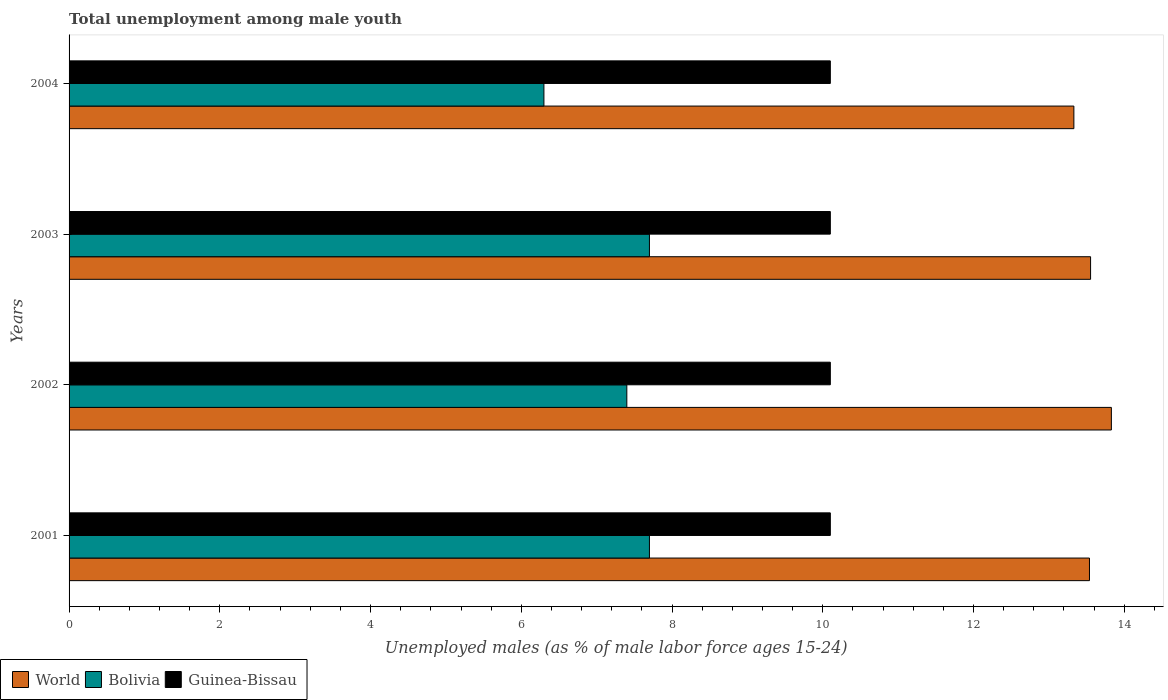How many different coloured bars are there?
Keep it short and to the point. 3. How many groups of bars are there?
Your answer should be very brief. 4. Are the number of bars on each tick of the Y-axis equal?
Offer a terse response. Yes. How many bars are there on the 2nd tick from the top?
Provide a short and direct response. 3. How many bars are there on the 2nd tick from the bottom?
Ensure brevity in your answer.  3. What is the label of the 3rd group of bars from the top?
Offer a terse response. 2002. In how many cases, is the number of bars for a given year not equal to the number of legend labels?
Keep it short and to the point. 0. What is the percentage of unemployed males in in World in 2004?
Give a very brief answer. 13.33. Across all years, what is the maximum percentage of unemployed males in in World?
Your response must be concise. 13.83. Across all years, what is the minimum percentage of unemployed males in in World?
Offer a terse response. 13.33. In which year was the percentage of unemployed males in in World minimum?
Make the answer very short. 2004. What is the total percentage of unemployed males in in Guinea-Bissau in the graph?
Provide a short and direct response. 40.4. What is the difference between the percentage of unemployed males in in World in 2001 and that in 2002?
Ensure brevity in your answer.  -0.29. What is the difference between the percentage of unemployed males in in Guinea-Bissau in 2001 and the percentage of unemployed males in in World in 2002?
Ensure brevity in your answer.  -3.73. What is the average percentage of unemployed males in in Guinea-Bissau per year?
Make the answer very short. 10.1. In the year 2003, what is the difference between the percentage of unemployed males in in Bolivia and percentage of unemployed males in in World?
Provide a short and direct response. -5.85. In how many years, is the percentage of unemployed males in in Bolivia greater than 9.6 %?
Provide a short and direct response. 0. Is the difference between the percentage of unemployed males in in Bolivia in 2002 and 2003 greater than the difference between the percentage of unemployed males in in World in 2002 and 2003?
Ensure brevity in your answer.  No. What is the difference between the highest and the lowest percentage of unemployed males in in Guinea-Bissau?
Your response must be concise. 0. What does the 3rd bar from the bottom in 2001 represents?
Provide a short and direct response. Guinea-Bissau. Are all the bars in the graph horizontal?
Give a very brief answer. Yes. How many years are there in the graph?
Give a very brief answer. 4. What is the difference between two consecutive major ticks on the X-axis?
Provide a short and direct response. 2. Are the values on the major ticks of X-axis written in scientific E-notation?
Offer a terse response. No. Does the graph contain any zero values?
Provide a short and direct response. No. Where does the legend appear in the graph?
Your answer should be compact. Bottom left. How many legend labels are there?
Keep it short and to the point. 3. How are the legend labels stacked?
Ensure brevity in your answer.  Horizontal. What is the title of the graph?
Offer a very short reply. Total unemployment among male youth. What is the label or title of the X-axis?
Keep it short and to the point. Unemployed males (as % of male labor force ages 15-24). What is the label or title of the Y-axis?
Your response must be concise. Years. What is the Unemployed males (as % of male labor force ages 15-24) in World in 2001?
Your answer should be very brief. 13.54. What is the Unemployed males (as % of male labor force ages 15-24) of Bolivia in 2001?
Ensure brevity in your answer.  7.7. What is the Unemployed males (as % of male labor force ages 15-24) of Guinea-Bissau in 2001?
Ensure brevity in your answer.  10.1. What is the Unemployed males (as % of male labor force ages 15-24) of World in 2002?
Keep it short and to the point. 13.83. What is the Unemployed males (as % of male labor force ages 15-24) in Bolivia in 2002?
Your answer should be very brief. 7.4. What is the Unemployed males (as % of male labor force ages 15-24) of Guinea-Bissau in 2002?
Offer a terse response. 10.1. What is the Unemployed males (as % of male labor force ages 15-24) of World in 2003?
Provide a succinct answer. 13.55. What is the Unemployed males (as % of male labor force ages 15-24) in Bolivia in 2003?
Your answer should be very brief. 7.7. What is the Unemployed males (as % of male labor force ages 15-24) in Guinea-Bissau in 2003?
Provide a succinct answer. 10.1. What is the Unemployed males (as % of male labor force ages 15-24) in World in 2004?
Your response must be concise. 13.33. What is the Unemployed males (as % of male labor force ages 15-24) in Bolivia in 2004?
Keep it short and to the point. 6.3. What is the Unemployed males (as % of male labor force ages 15-24) of Guinea-Bissau in 2004?
Offer a terse response. 10.1. Across all years, what is the maximum Unemployed males (as % of male labor force ages 15-24) of World?
Make the answer very short. 13.83. Across all years, what is the maximum Unemployed males (as % of male labor force ages 15-24) of Bolivia?
Offer a very short reply. 7.7. Across all years, what is the maximum Unemployed males (as % of male labor force ages 15-24) in Guinea-Bissau?
Your answer should be compact. 10.1. Across all years, what is the minimum Unemployed males (as % of male labor force ages 15-24) in World?
Your answer should be compact. 13.33. Across all years, what is the minimum Unemployed males (as % of male labor force ages 15-24) of Bolivia?
Give a very brief answer. 6.3. Across all years, what is the minimum Unemployed males (as % of male labor force ages 15-24) of Guinea-Bissau?
Provide a short and direct response. 10.1. What is the total Unemployed males (as % of male labor force ages 15-24) in World in the graph?
Provide a short and direct response. 54.25. What is the total Unemployed males (as % of male labor force ages 15-24) in Bolivia in the graph?
Give a very brief answer. 29.1. What is the total Unemployed males (as % of male labor force ages 15-24) in Guinea-Bissau in the graph?
Ensure brevity in your answer.  40.4. What is the difference between the Unemployed males (as % of male labor force ages 15-24) of World in 2001 and that in 2002?
Give a very brief answer. -0.29. What is the difference between the Unemployed males (as % of male labor force ages 15-24) of Bolivia in 2001 and that in 2002?
Your response must be concise. 0.3. What is the difference between the Unemployed males (as % of male labor force ages 15-24) in Guinea-Bissau in 2001 and that in 2002?
Make the answer very short. 0. What is the difference between the Unemployed males (as % of male labor force ages 15-24) in World in 2001 and that in 2003?
Offer a terse response. -0.01. What is the difference between the Unemployed males (as % of male labor force ages 15-24) of Bolivia in 2001 and that in 2003?
Offer a terse response. 0. What is the difference between the Unemployed males (as % of male labor force ages 15-24) of World in 2001 and that in 2004?
Offer a terse response. 0.21. What is the difference between the Unemployed males (as % of male labor force ages 15-24) of World in 2002 and that in 2003?
Make the answer very short. 0.28. What is the difference between the Unemployed males (as % of male labor force ages 15-24) of Bolivia in 2002 and that in 2003?
Give a very brief answer. -0.3. What is the difference between the Unemployed males (as % of male labor force ages 15-24) of Guinea-Bissau in 2002 and that in 2003?
Provide a short and direct response. 0. What is the difference between the Unemployed males (as % of male labor force ages 15-24) of World in 2002 and that in 2004?
Offer a terse response. 0.5. What is the difference between the Unemployed males (as % of male labor force ages 15-24) in World in 2003 and that in 2004?
Your answer should be compact. 0.22. What is the difference between the Unemployed males (as % of male labor force ages 15-24) of World in 2001 and the Unemployed males (as % of male labor force ages 15-24) of Bolivia in 2002?
Your answer should be compact. 6.14. What is the difference between the Unemployed males (as % of male labor force ages 15-24) in World in 2001 and the Unemployed males (as % of male labor force ages 15-24) in Guinea-Bissau in 2002?
Offer a terse response. 3.44. What is the difference between the Unemployed males (as % of male labor force ages 15-24) in Bolivia in 2001 and the Unemployed males (as % of male labor force ages 15-24) in Guinea-Bissau in 2002?
Offer a very short reply. -2.4. What is the difference between the Unemployed males (as % of male labor force ages 15-24) in World in 2001 and the Unemployed males (as % of male labor force ages 15-24) in Bolivia in 2003?
Your response must be concise. 5.84. What is the difference between the Unemployed males (as % of male labor force ages 15-24) in World in 2001 and the Unemployed males (as % of male labor force ages 15-24) in Guinea-Bissau in 2003?
Make the answer very short. 3.44. What is the difference between the Unemployed males (as % of male labor force ages 15-24) in Bolivia in 2001 and the Unemployed males (as % of male labor force ages 15-24) in Guinea-Bissau in 2003?
Provide a short and direct response. -2.4. What is the difference between the Unemployed males (as % of male labor force ages 15-24) of World in 2001 and the Unemployed males (as % of male labor force ages 15-24) of Bolivia in 2004?
Your response must be concise. 7.24. What is the difference between the Unemployed males (as % of male labor force ages 15-24) of World in 2001 and the Unemployed males (as % of male labor force ages 15-24) of Guinea-Bissau in 2004?
Your response must be concise. 3.44. What is the difference between the Unemployed males (as % of male labor force ages 15-24) in World in 2002 and the Unemployed males (as % of male labor force ages 15-24) in Bolivia in 2003?
Ensure brevity in your answer.  6.13. What is the difference between the Unemployed males (as % of male labor force ages 15-24) of World in 2002 and the Unemployed males (as % of male labor force ages 15-24) of Guinea-Bissau in 2003?
Your answer should be very brief. 3.73. What is the difference between the Unemployed males (as % of male labor force ages 15-24) in Bolivia in 2002 and the Unemployed males (as % of male labor force ages 15-24) in Guinea-Bissau in 2003?
Offer a terse response. -2.7. What is the difference between the Unemployed males (as % of male labor force ages 15-24) of World in 2002 and the Unemployed males (as % of male labor force ages 15-24) of Bolivia in 2004?
Offer a terse response. 7.53. What is the difference between the Unemployed males (as % of male labor force ages 15-24) in World in 2002 and the Unemployed males (as % of male labor force ages 15-24) in Guinea-Bissau in 2004?
Your answer should be very brief. 3.73. What is the difference between the Unemployed males (as % of male labor force ages 15-24) in Bolivia in 2002 and the Unemployed males (as % of male labor force ages 15-24) in Guinea-Bissau in 2004?
Offer a terse response. -2.7. What is the difference between the Unemployed males (as % of male labor force ages 15-24) in World in 2003 and the Unemployed males (as % of male labor force ages 15-24) in Bolivia in 2004?
Give a very brief answer. 7.25. What is the difference between the Unemployed males (as % of male labor force ages 15-24) in World in 2003 and the Unemployed males (as % of male labor force ages 15-24) in Guinea-Bissau in 2004?
Provide a short and direct response. 3.45. What is the average Unemployed males (as % of male labor force ages 15-24) of World per year?
Offer a very short reply. 13.56. What is the average Unemployed males (as % of male labor force ages 15-24) in Bolivia per year?
Offer a very short reply. 7.28. In the year 2001, what is the difference between the Unemployed males (as % of male labor force ages 15-24) of World and Unemployed males (as % of male labor force ages 15-24) of Bolivia?
Provide a succinct answer. 5.84. In the year 2001, what is the difference between the Unemployed males (as % of male labor force ages 15-24) in World and Unemployed males (as % of male labor force ages 15-24) in Guinea-Bissau?
Offer a very short reply. 3.44. In the year 2002, what is the difference between the Unemployed males (as % of male labor force ages 15-24) of World and Unemployed males (as % of male labor force ages 15-24) of Bolivia?
Provide a short and direct response. 6.43. In the year 2002, what is the difference between the Unemployed males (as % of male labor force ages 15-24) of World and Unemployed males (as % of male labor force ages 15-24) of Guinea-Bissau?
Provide a short and direct response. 3.73. In the year 2003, what is the difference between the Unemployed males (as % of male labor force ages 15-24) in World and Unemployed males (as % of male labor force ages 15-24) in Bolivia?
Keep it short and to the point. 5.85. In the year 2003, what is the difference between the Unemployed males (as % of male labor force ages 15-24) in World and Unemployed males (as % of male labor force ages 15-24) in Guinea-Bissau?
Make the answer very short. 3.45. In the year 2004, what is the difference between the Unemployed males (as % of male labor force ages 15-24) of World and Unemployed males (as % of male labor force ages 15-24) of Bolivia?
Provide a short and direct response. 7.03. In the year 2004, what is the difference between the Unemployed males (as % of male labor force ages 15-24) in World and Unemployed males (as % of male labor force ages 15-24) in Guinea-Bissau?
Offer a terse response. 3.23. In the year 2004, what is the difference between the Unemployed males (as % of male labor force ages 15-24) of Bolivia and Unemployed males (as % of male labor force ages 15-24) of Guinea-Bissau?
Make the answer very short. -3.8. What is the ratio of the Unemployed males (as % of male labor force ages 15-24) in World in 2001 to that in 2002?
Your response must be concise. 0.98. What is the ratio of the Unemployed males (as % of male labor force ages 15-24) in Bolivia in 2001 to that in 2002?
Provide a short and direct response. 1.04. What is the ratio of the Unemployed males (as % of male labor force ages 15-24) of Guinea-Bissau in 2001 to that in 2002?
Provide a succinct answer. 1. What is the ratio of the Unemployed males (as % of male labor force ages 15-24) of World in 2001 to that in 2004?
Offer a very short reply. 1.02. What is the ratio of the Unemployed males (as % of male labor force ages 15-24) in Bolivia in 2001 to that in 2004?
Provide a succinct answer. 1.22. What is the ratio of the Unemployed males (as % of male labor force ages 15-24) in World in 2002 to that in 2003?
Offer a terse response. 1.02. What is the ratio of the Unemployed males (as % of male labor force ages 15-24) in World in 2002 to that in 2004?
Your response must be concise. 1.04. What is the ratio of the Unemployed males (as % of male labor force ages 15-24) in Bolivia in 2002 to that in 2004?
Provide a short and direct response. 1.17. What is the ratio of the Unemployed males (as % of male labor force ages 15-24) in Guinea-Bissau in 2002 to that in 2004?
Provide a succinct answer. 1. What is the ratio of the Unemployed males (as % of male labor force ages 15-24) in World in 2003 to that in 2004?
Offer a very short reply. 1.02. What is the ratio of the Unemployed males (as % of male labor force ages 15-24) of Bolivia in 2003 to that in 2004?
Your answer should be compact. 1.22. What is the difference between the highest and the second highest Unemployed males (as % of male labor force ages 15-24) of World?
Make the answer very short. 0.28. What is the difference between the highest and the second highest Unemployed males (as % of male labor force ages 15-24) of Bolivia?
Offer a very short reply. 0. What is the difference between the highest and the lowest Unemployed males (as % of male labor force ages 15-24) of World?
Provide a short and direct response. 0.5. What is the difference between the highest and the lowest Unemployed males (as % of male labor force ages 15-24) of Bolivia?
Ensure brevity in your answer.  1.4. 